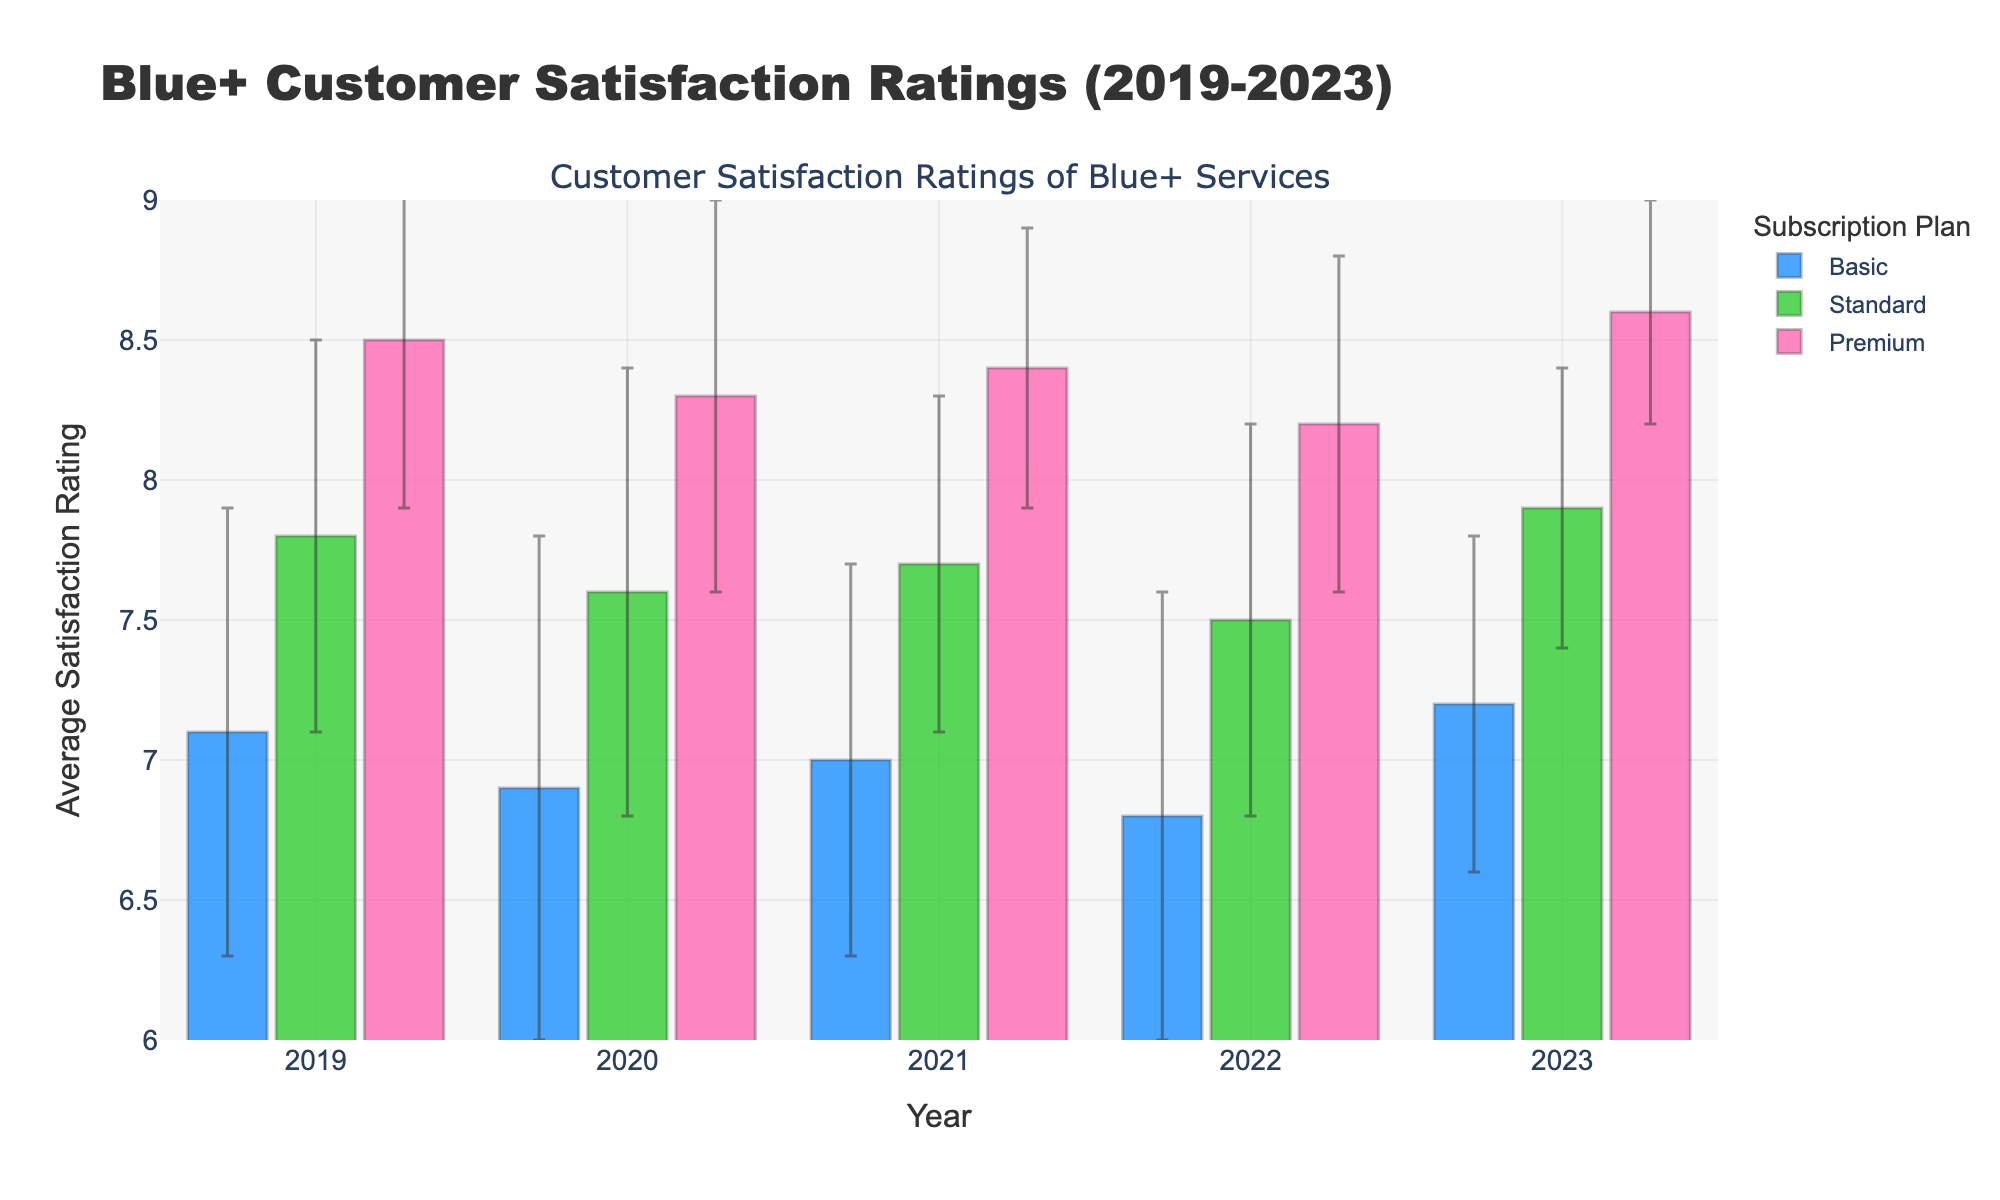What's the title of the figure? The title of the figure is located at the top and reads, "Blue+ Customer Satisfaction Ratings (2019-2023)."
Answer: Blue+ Customer Satisfaction Ratings (2019-2023) Which subscription plan had the highest satisfaction rating in 2023? By looking at the highest bar in 2023, the Premium subscription plan had the highest satisfaction rating.
Answer: Premium What were the satisfaction ratings for the Standard plan across the years? To answer, we look at the bars for the Standard plan in each year. The ratings are 7.8 (2019), 7.6 (2020), 7.7 (2021), 7.5 (2022), and 7.9 (2023).
Answer: 7.8, 7.6, 7.7, 7.5, 7.9 Which year had the lowest satisfaction rating for the Basic plan? Look for the shortest bar associated with the Basic plan. It's in 2022 with a rating of 6.8.
Answer: 2022 How much did the satisfaction rating for the Premium plan change between 2022 and 2023? The Premium ratings were 8.2 in 2022 and 8.6 in 2023. Calculate the difference: 8.6 - 8.2 = 0.4.
Answer: 0.4 In which year did the difference between the Standard and Basic plan satisfaction ratings change the most? Compute the difference for each year: 2019 (0.7), 2020 (0.7), 2021 (0.7), 2022 (0.7), and 2023 (0.7). All differences are equal, so the difference didn’t change across the years.
Answer: None (same difference each year) Which subscription plan had the smallest change in customer satisfaction from 2019 to 2023? Compare changes over the years for each plan. Basic: (7.2-7.1 = 0.1), Standard: (7.9-7.8 = 0.1), Premium: (8.6-8.5 = 0.1). All plans had the same change.
Answer: All (equal change) Describe the pattern of error bars for the Basic plan over the years. The error bars represent standard deviation. Visually inspecting the Basic plan, the error bars' lengths slightly vary but generally remain below 1, reflecting the spread of satisfaction scores around the average.
Answer: Slight variation, generally below 1 Compare the customer satisfaction rating trends between the Standard and Premium plans from 2019 to 2023. Both plans show a stable trend, but Premium consistently shows higher ratings. Across the years, while Standard slightly fluctuates, Premium consistently trends upward.
Answer: Premium more stable and consistently higher 